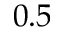<formula> <loc_0><loc_0><loc_500><loc_500>0 . 5</formula> 